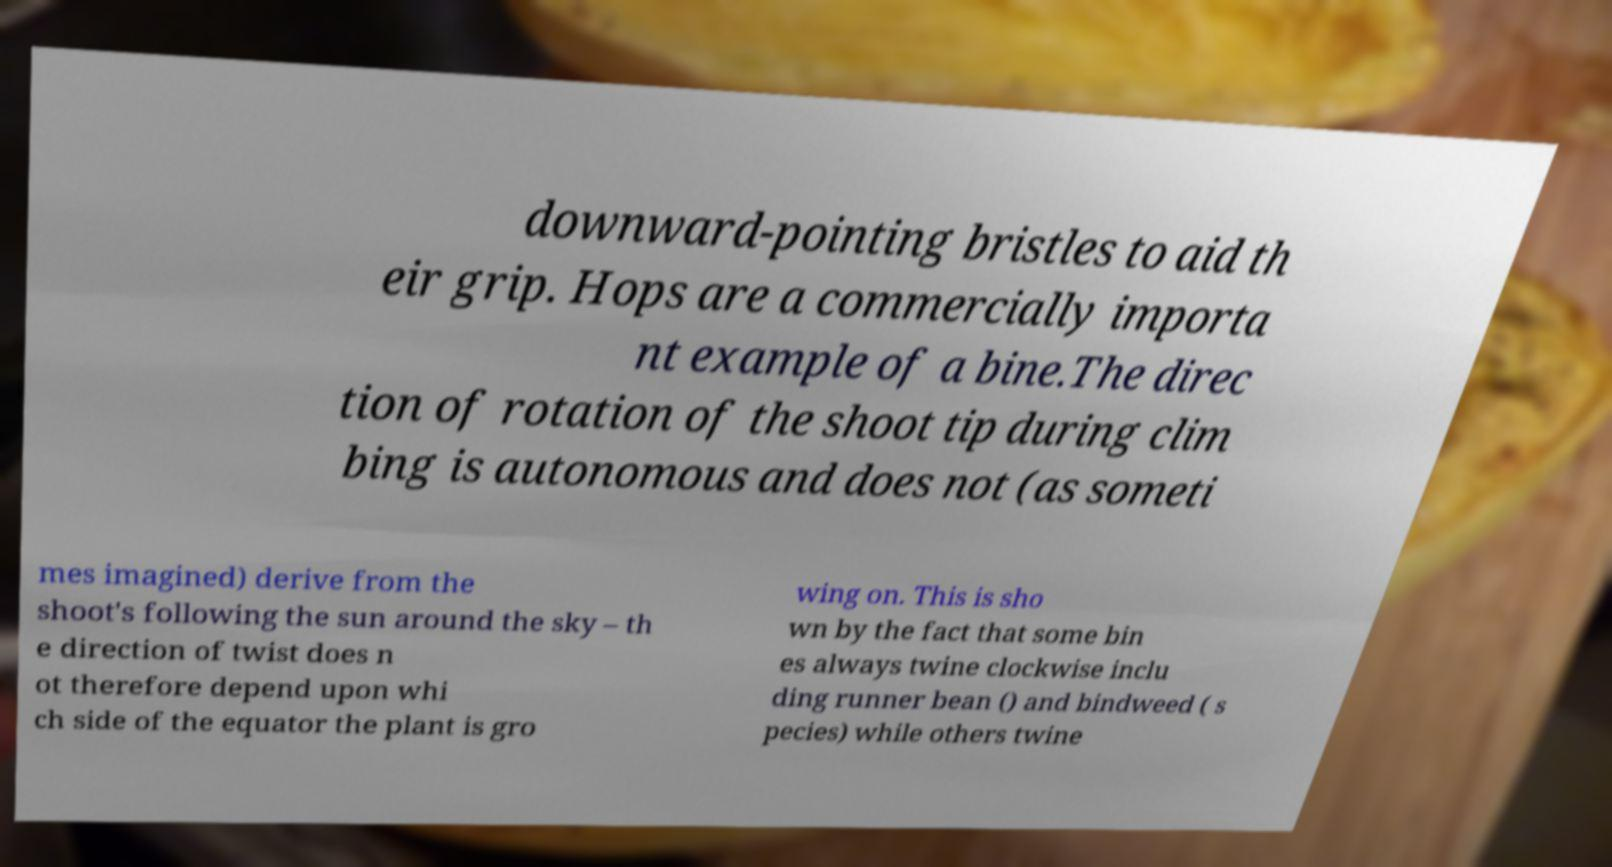Could you assist in decoding the text presented in this image and type it out clearly? downward-pointing bristles to aid th eir grip. Hops are a commercially importa nt example of a bine.The direc tion of rotation of the shoot tip during clim bing is autonomous and does not (as someti mes imagined) derive from the shoot's following the sun around the sky – th e direction of twist does n ot therefore depend upon whi ch side of the equator the plant is gro wing on. This is sho wn by the fact that some bin es always twine clockwise inclu ding runner bean () and bindweed ( s pecies) while others twine 